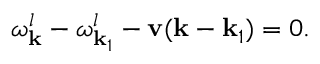<formula> <loc_0><loc_0><loc_500><loc_500>\omega _ { k } ^ { l } - \omega _ { { k } _ { 1 } } ^ { l } - { v } ( { k } - { k } _ { 1 } ) = 0 .</formula> 